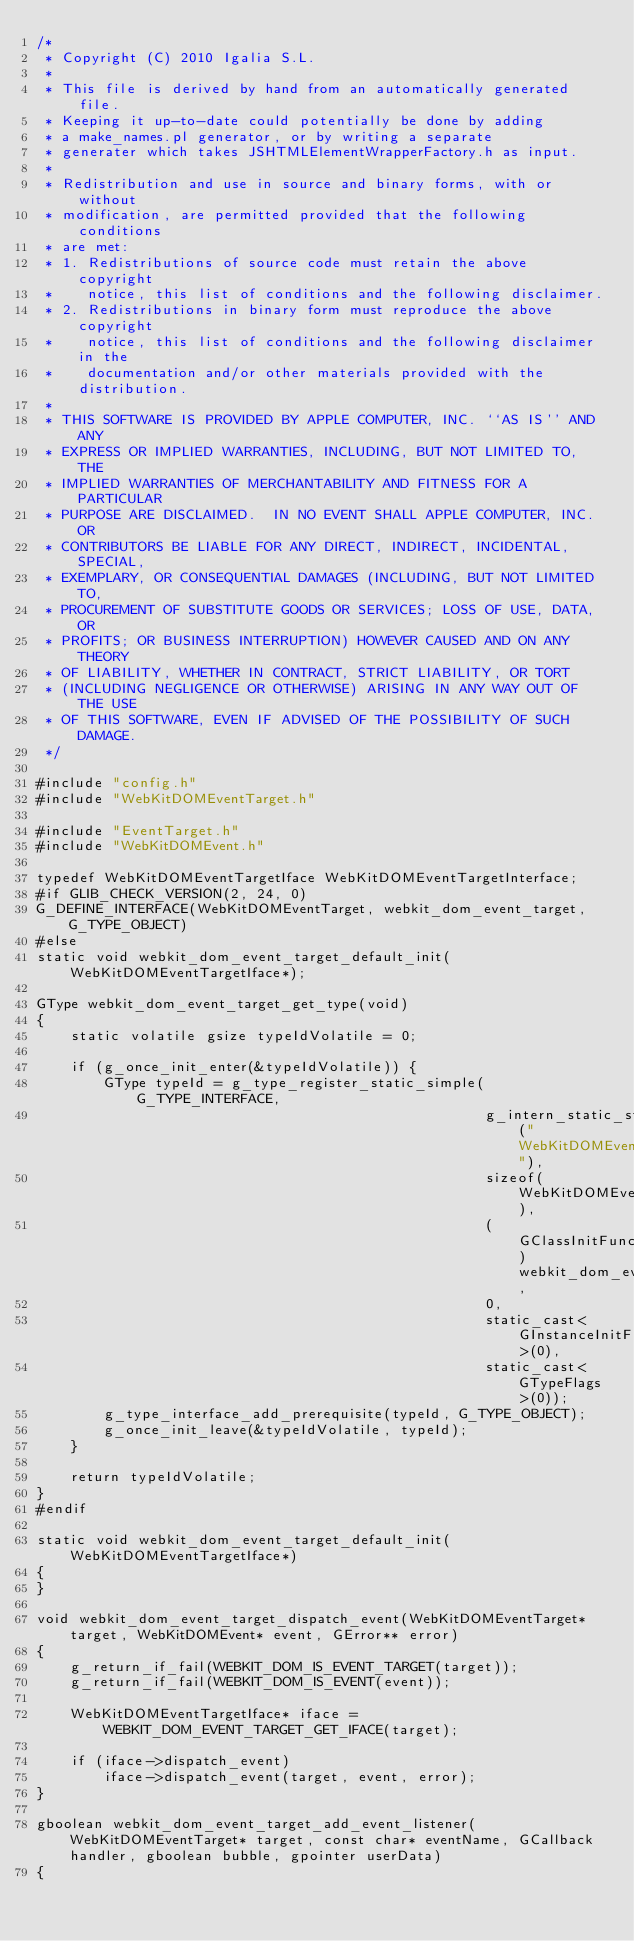Convert code to text. <code><loc_0><loc_0><loc_500><loc_500><_C++_>/*
 * Copyright (C) 2010 Igalia S.L.
 *
 * This file is derived by hand from an automatically generated file.
 * Keeping it up-to-date could potentially be done by adding
 * a make_names.pl generator, or by writing a separate
 * generater which takes JSHTMLElementWrapperFactory.h as input.
 *
 * Redistribution and use in source and binary forms, with or without
 * modification, are permitted provided that the following conditions
 * are met:
 * 1. Redistributions of source code must retain the above copyright
 *    notice, this list of conditions and the following disclaimer.
 * 2. Redistributions in binary form must reproduce the above copyright
 *    notice, this list of conditions and the following disclaimer in the
 *    documentation and/or other materials provided with the distribution.
 *
 * THIS SOFTWARE IS PROVIDED BY APPLE COMPUTER, INC. ``AS IS'' AND ANY
 * EXPRESS OR IMPLIED WARRANTIES, INCLUDING, BUT NOT LIMITED TO, THE
 * IMPLIED WARRANTIES OF MERCHANTABILITY AND FITNESS FOR A PARTICULAR
 * PURPOSE ARE DISCLAIMED.  IN NO EVENT SHALL APPLE COMPUTER, INC. OR
 * CONTRIBUTORS BE LIABLE FOR ANY DIRECT, INDIRECT, INCIDENTAL, SPECIAL,
 * EXEMPLARY, OR CONSEQUENTIAL DAMAGES (INCLUDING, BUT NOT LIMITED TO,
 * PROCUREMENT OF SUBSTITUTE GOODS OR SERVICES; LOSS OF USE, DATA, OR
 * PROFITS; OR BUSINESS INTERRUPTION) HOWEVER CAUSED AND ON ANY THEORY
 * OF LIABILITY, WHETHER IN CONTRACT, STRICT LIABILITY, OR TORT
 * (INCLUDING NEGLIGENCE OR OTHERWISE) ARISING IN ANY WAY OUT OF THE USE
 * OF THIS SOFTWARE, EVEN IF ADVISED OF THE POSSIBILITY OF SUCH DAMAGE.
 */

#include "config.h"
#include "WebKitDOMEventTarget.h"

#include "EventTarget.h"
#include "WebKitDOMEvent.h"

typedef WebKitDOMEventTargetIface WebKitDOMEventTargetInterface;
#if GLIB_CHECK_VERSION(2, 24, 0)
G_DEFINE_INTERFACE(WebKitDOMEventTarget, webkit_dom_event_target, G_TYPE_OBJECT)
#else
static void webkit_dom_event_target_default_init(WebKitDOMEventTargetIface*);

GType webkit_dom_event_target_get_type(void)
{
    static volatile gsize typeIdVolatile = 0;

    if (g_once_init_enter(&typeIdVolatile)) {
        GType typeId = g_type_register_static_simple(G_TYPE_INTERFACE,
                                                     g_intern_static_string("WebKitDOMEventTarget"),
                                                     sizeof(WebKitDOMEventTargetInterface),
                                                     (GClassInitFunc)webkit_dom_event_target_default_init,
                                                     0,
                                                     static_cast<GInstanceInitFunc>(0),
                                                     static_cast<GTypeFlags>(0));
        g_type_interface_add_prerequisite(typeId, G_TYPE_OBJECT);
        g_once_init_leave(&typeIdVolatile, typeId);
    }

    return typeIdVolatile;
}
#endif

static void webkit_dom_event_target_default_init(WebKitDOMEventTargetIface*)
{
}

void webkit_dom_event_target_dispatch_event(WebKitDOMEventTarget* target, WebKitDOMEvent* event, GError** error)
{
    g_return_if_fail(WEBKIT_DOM_IS_EVENT_TARGET(target));
    g_return_if_fail(WEBKIT_DOM_IS_EVENT(event));

    WebKitDOMEventTargetIface* iface = WEBKIT_DOM_EVENT_TARGET_GET_IFACE(target);

    if (iface->dispatch_event)
        iface->dispatch_event(target, event, error);
}

gboolean webkit_dom_event_target_add_event_listener(WebKitDOMEventTarget* target, const char* eventName, GCallback handler, gboolean bubble, gpointer userData)
{
</code> 